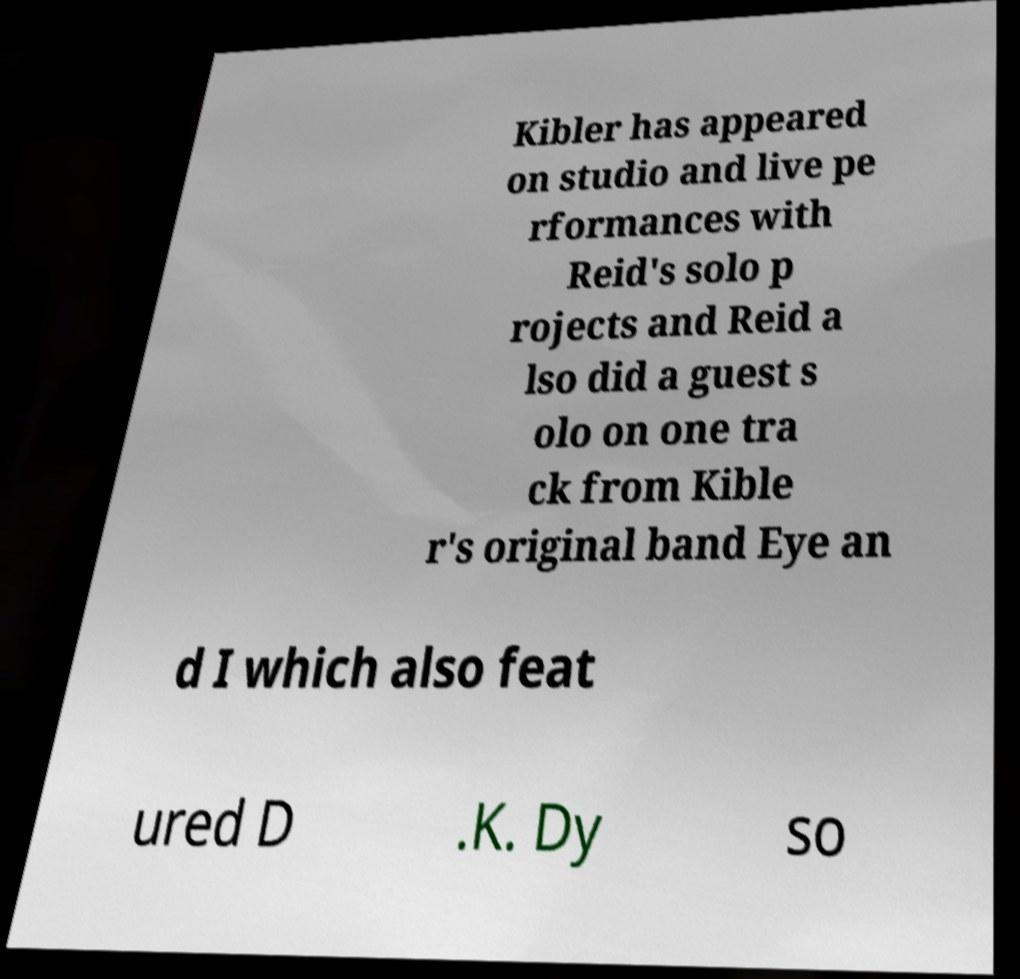Can you read and provide the text displayed in the image?This photo seems to have some interesting text. Can you extract and type it out for me? Kibler has appeared on studio and live pe rformances with Reid's solo p rojects and Reid a lso did a guest s olo on one tra ck from Kible r's original band Eye an d I which also feat ured D .K. Dy so 